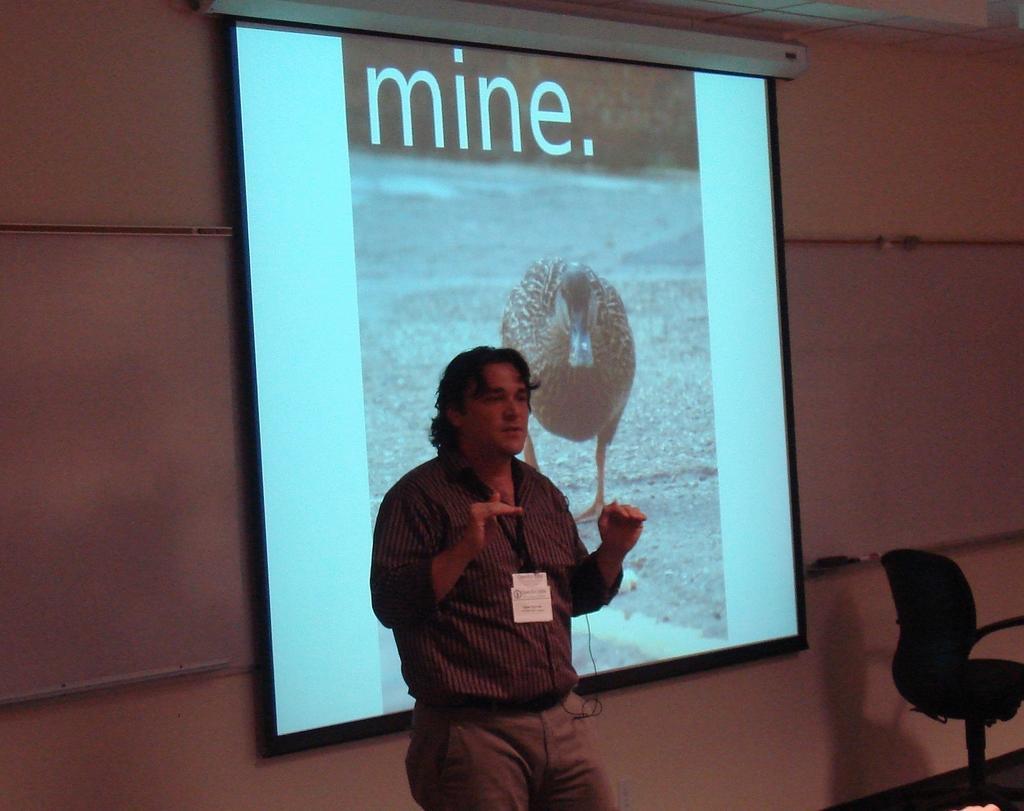Please provide a concise description of this image. In this image I can see a man is standing next to a projector screen. I can also see a chair. 